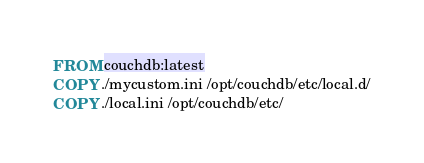<code> <loc_0><loc_0><loc_500><loc_500><_Dockerfile_>FROM couchdb:latest
COPY ./mycustom.ini /opt/couchdb/etc/local.d/
COPY ./local.ini /opt/couchdb/etc/
</code> 